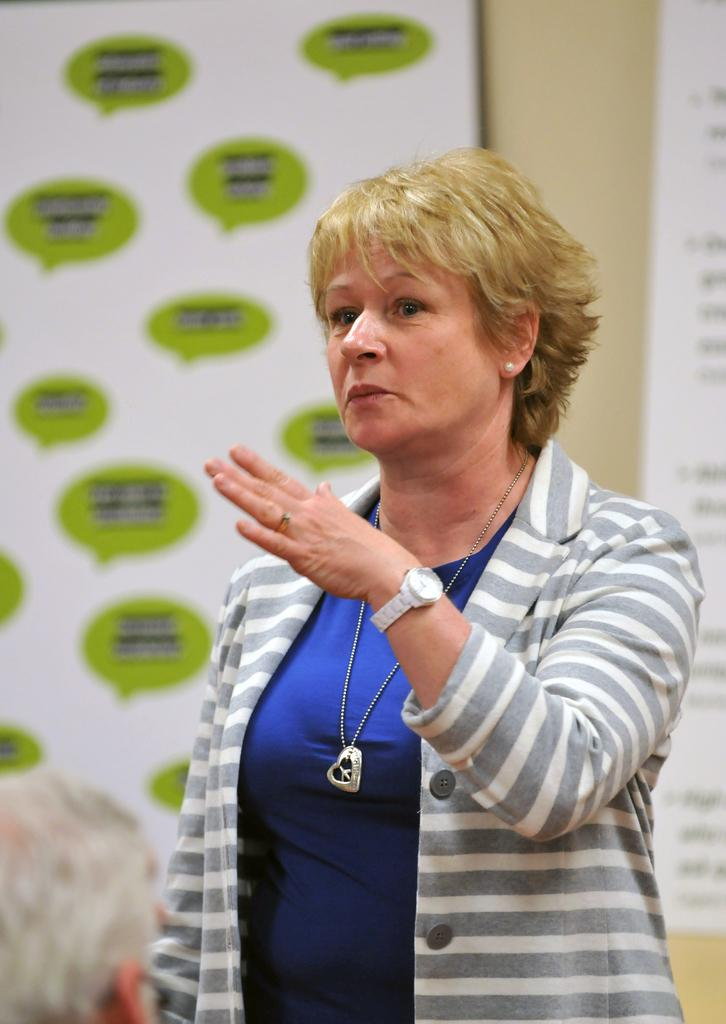What is there is a woman with a specific hair color in the image. What is her hair color? There is a blond-haired woman in the image. What is the woman wearing in the image? The woman is wearing a white and grey sweatshirt. Where is the woman positioned in the image? The woman is standing in the middle of the image. What can be seen on the wall behind the woman? There are banners on the wall behind the woman. What type of education can be seen in the image? There is no indication of education in the image; it features a woman standing in the middle of the image with banners on the wall behind her. How many bubbles are visible in the image? There are no bubbles present in the image. 